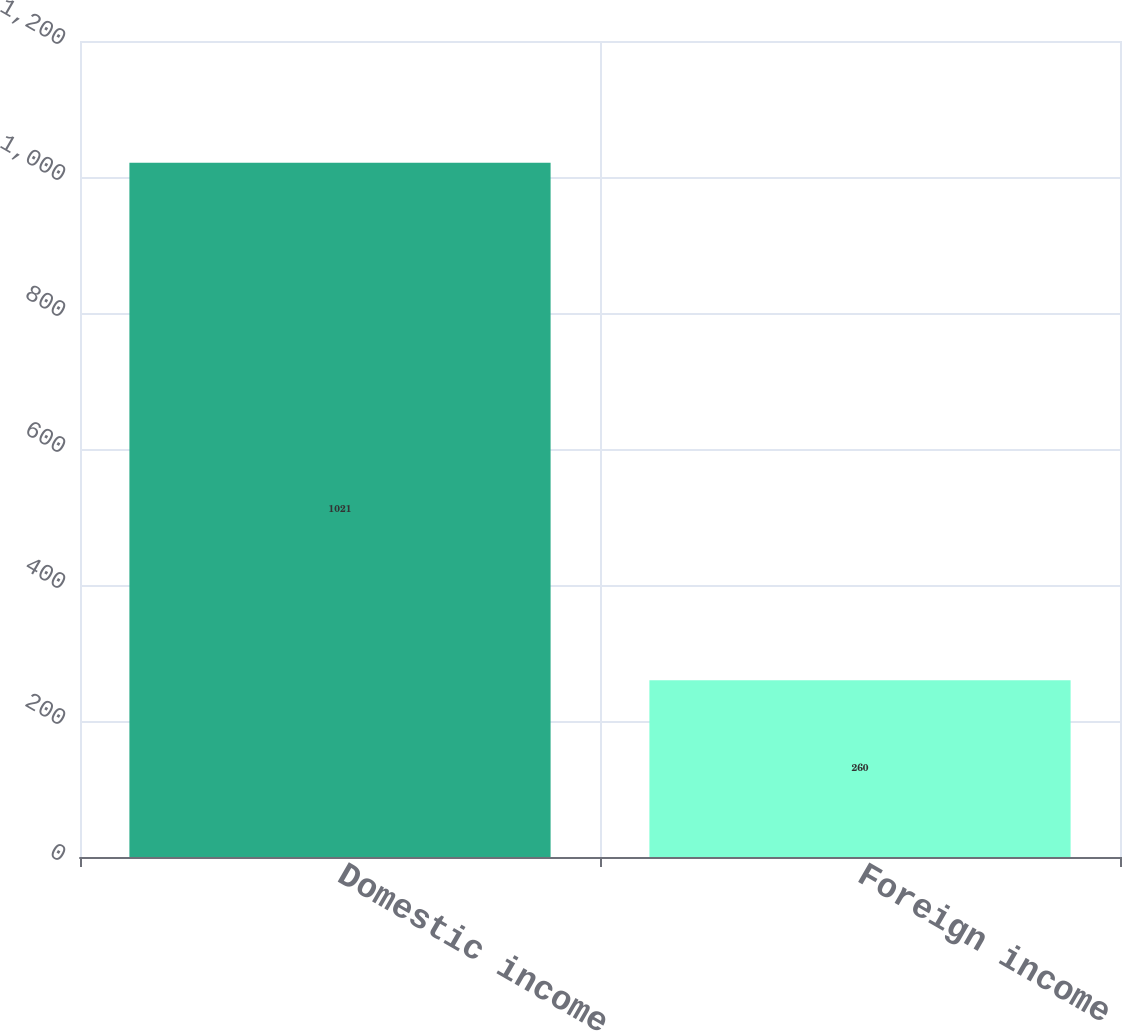Convert chart. <chart><loc_0><loc_0><loc_500><loc_500><bar_chart><fcel>Domestic income<fcel>Foreign income<nl><fcel>1021<fcel>260<nl></chart> 